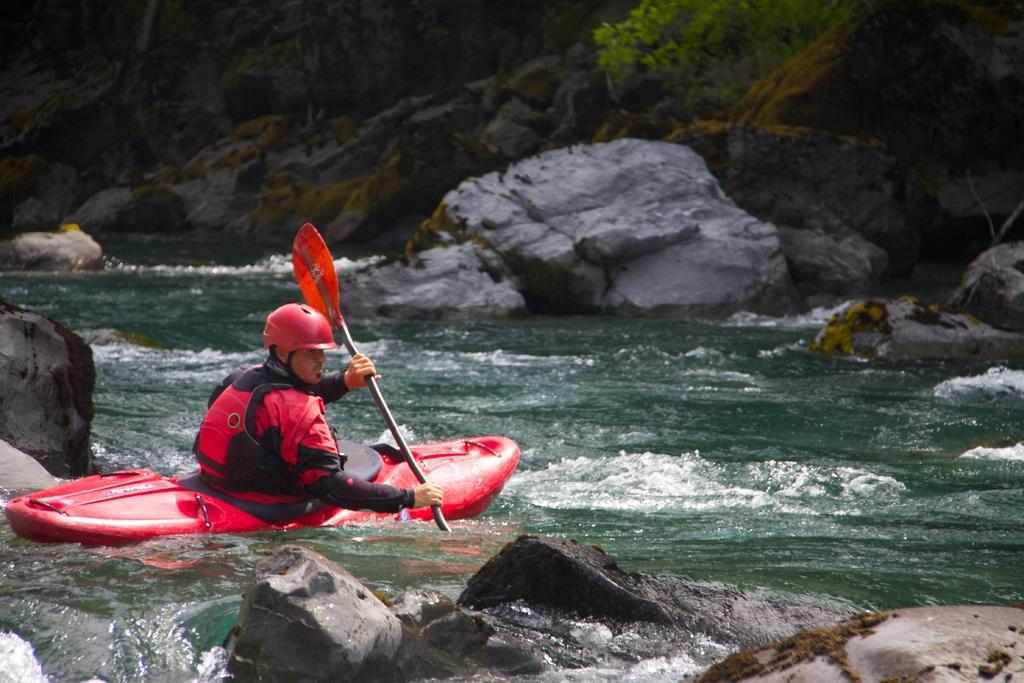What is the person in the image doing? The person is river rafting in the water. What is the environment like in the image? There are rocks and plants visible in the image. How many spiders are visible on the person's raft in the image? There are no spiders visible on the person's raft in the image. What advice does the creator of the image give to viewers? The creator of the image is not present in the image, so it is not possible to determine any advice they might give. 